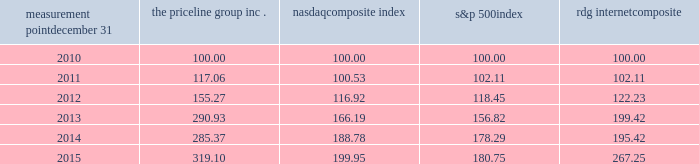Measurement point december 31 the priceline group nasdaq composite index s&p 500 rdg internet composite .

What was the difference in percentage change between the priceline group inc . and the nasdaq composite index for the five years ended 2015? 
Computations: (((319.10 - 100) / 100) - ((199.95 - 100) / 100))
Answer: 1.1915. 